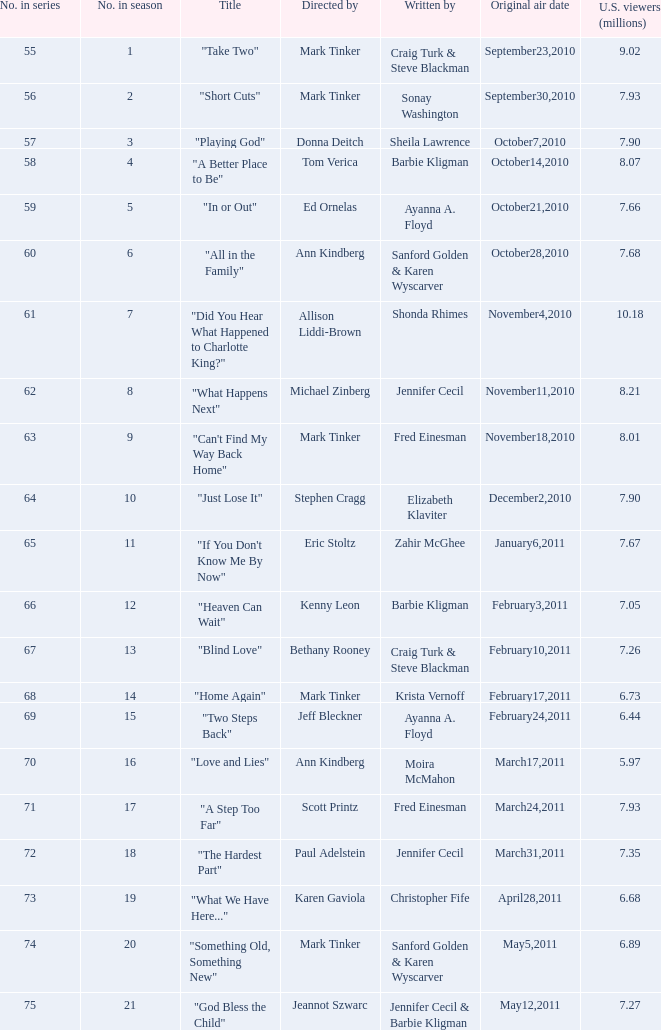In the season, which episode was directed by paul adelstein? 18.0. 